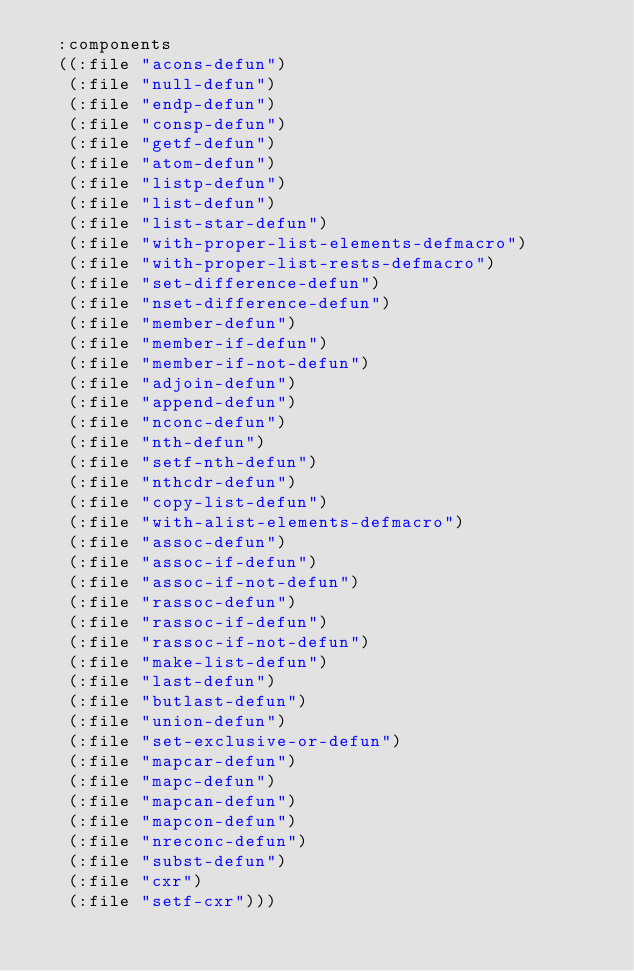<code> <loc_0><loc_0><loc_500><loc_500><_Lisp_>  :components
  ((:file "acons-defun")
   (:file "null-defun")
   (:file "endp-defun")
   (:file "consp-defun")
   (:file "getf-defun")
   (:file "atom-defun")
   (:file "listp-defun")
   (:file "list-defun")
   (:file "list-star-defun")
   (:file "with-proper-list-elements-defmacro")
   (:file "with-proper-list-rests-defmacro")
   (:file "set-difference-defun")
   (:file "nset-difference-defun")
   (:file "member-defun")
   (:file "member-if-defun")
   (:file "member-if-not-defun")
   (:file "adjoin-defun")
   (:file "append-defun")
   (:file "nconc-defun")
   (:file "nth-defun")
   (:file "setf-nth-defun")
   (:file "nthcdr-defun")
   (:file "copy-list-defun")
   (:file "with-alist-elements-defmacro")
   (:file "assoc-defun")
   (:file "assoc-if-defun")
   (:file "assoc-if-not-defun")
   (:file "rassoc-defun")
   (:file "rassoc-if-defun")
   (:file "rassoc-if-not-defun")
   (:file "make-list-defun")
   (:file "last-defun")
   (:file "butlast-defun")
   (:file "union-defun")
   (:file "set-exclusive-or-defun")
   (:file "mapcar-defun")
   (:file "mapc-defun")
   (:file "mapcan-defun")
   (:file "mapcon-defun")
   (:file "nreconc-defun")
   (:file "subst-defun")
   (:file "cxr")
   (:file "setf-cxr")))
</code> 